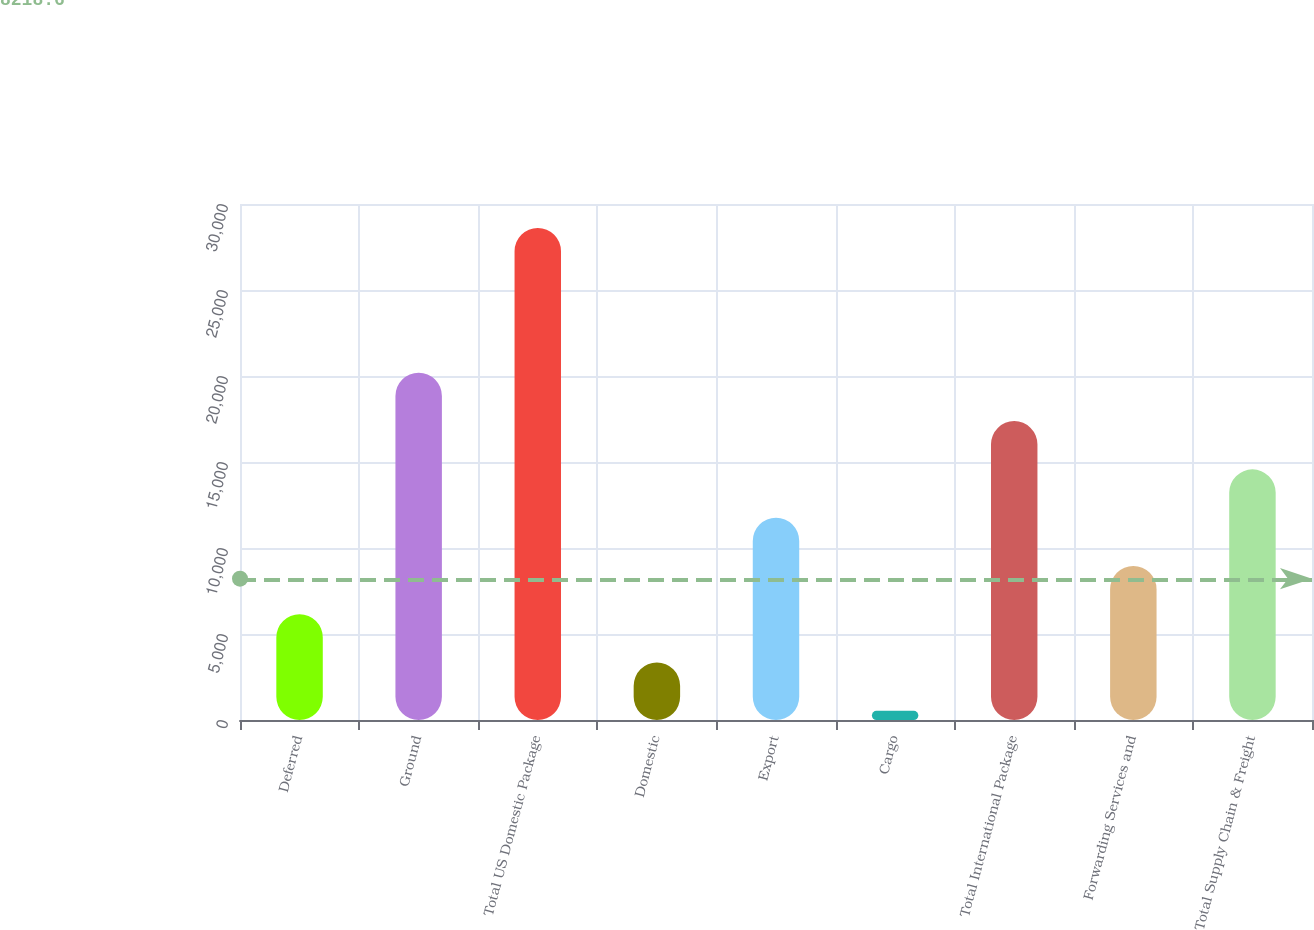Convert chart to OTSL. <chart><loc_0><loc_0><loc_500><loc_500><bar_chart><fcel>Deferred<fcel>Ground<fcel>Total US Domestic Package<fcel>Domestic<fcel>Export<fcel>Cargo<fcel>Total International Package<fcel>Forwarding Services and<fcel>Total Supply Chain & Freight<nl><fcel>6148.4<fcel>20186.9<fcel>28610<fcel>3340.7<fcel>11763.8<fcel>533<fcel>17379.2<fcel>8956.1<fcel>14571.5<nl></chart> 